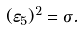<formula> <loc_0><loc_0><loc_500><loc_500>( \varepsilon _ { 5 } ) ^ { 2 } = \sigma .</formula> 